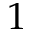<formula> <loc_0><loc_0><loc_500><loc_500>1</formula> 